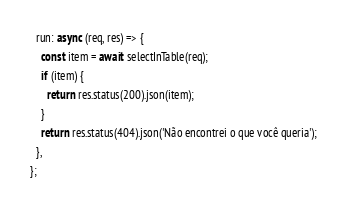<code> <loc_0><loc_0><loc_500><loc_500><_JavaScript_>  run: async (req, res) => {
    const item = await selectInTable(req);
    if (item) {
      return res.status(200).json(item);
    }
    return res.status(404).json('Não encontrei o que você queria');
  },
};
</code> 